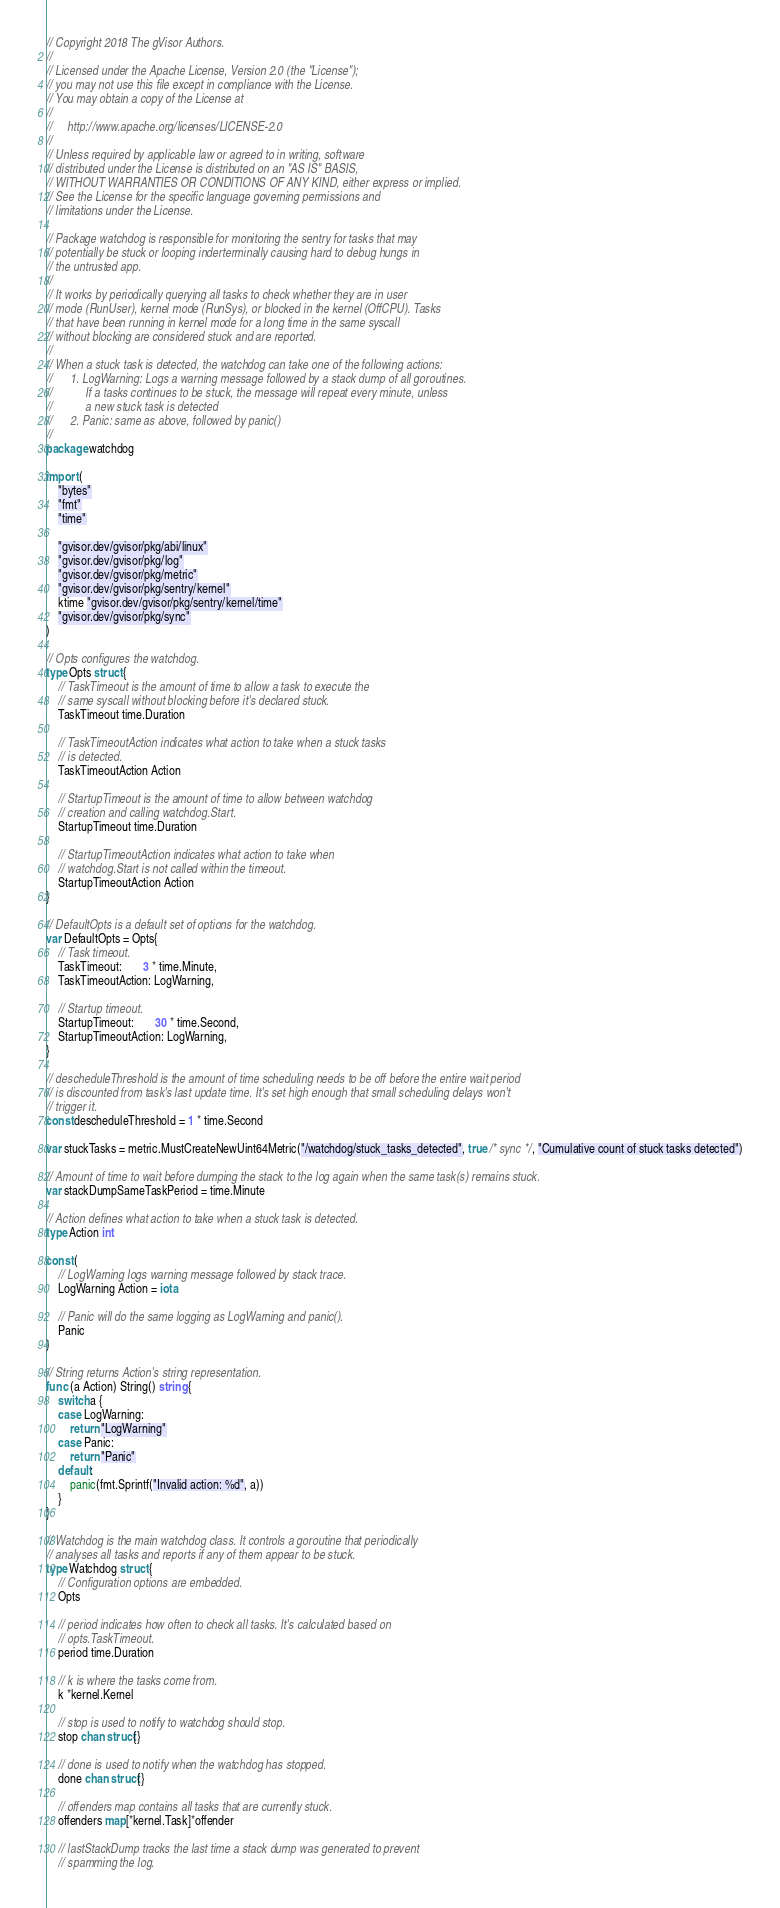<code> <loc_0><loc_0><loc_500><loc_500><_Go_>// Copyright 2018 The gVisor Authors.
//
// Licensed under the Apache License, Version 2.0 (the "License");
// you may not use this file except in compliance with the License.
// You may obtain a copy of the License at
//
//     http://www.apache.org/licenses/LICENSE-2.0
//
// Unless required by applicable law or agreed to in writing, software
// distributed under the License is distributed on an "AS IS" BASIS,
// WITHOUT WARRANTIES OR CONDITIONS OF ANY KIND, either express or implied.
// See the License for the specific language governing permissions and
// limitations under the License.

// Package watchdog is responsible for monitoring the sentry for tasks that may
// potentially be stuck or looping inderterminally causing hard to debug hungs in
// the untrusted app.
//
// It works by periodically querying all tasks to check whether they are in user
// mode (RunUser), kernel mode (RunSys), or blocked in the kernel (OffCPU). Tasks
// that have been running in kernel mode for a long time in the same syscall
// without blocking are considered stuck and are reported.
//
// When a stuck task is detected, the watchdog can take one of the following actions:
//		1. LogWarning: Logs a warning message followed by a stack dump of all goroutines.
//			 If a tasks continues to be stuck, the message will repeat every minute, unless
//			 a new stuck task is detected
//		2. Panic: same as above, followed by panic()
//
package watchdog

import (
	"bytes"
	"fmt"
	"time"

	"gvisor.dev/gvisor/pkg/abi/linux"
	"gvisor.dev/gvisor/pkg/log"
	"gvisor.dev/gvisor/pkg/metric"
	"gvisor.dev/gvisor/pkg/sentry/kernel"
	ktime "gvisor.dev/gvisor/pkg/sentry/kernel/time"
	"gvisor.dev/gvisor/pkg/sync"
)

// Opts configures the watchdog.
type Opts struct {
	// TaskTimeout is the amount of time to allow a task to execute the
	// same syscall without blocking before it's declared stuck.
	TaskTimeout time.Duration

	// TaskTimeoutAction indicates what action to take when a stuck tasks
	// is detected.
	TaskTimeoutAction Action

	// StartupTimeout is the amount of time to allow between watchdog
	// creation and calling watchdog.Start.
	StartupTimeout time.Duration

	// StartupTimeoutAction indicates what action to take when
	// watchdog.Start is not called within the timeout.
	StartupTimeoutAction Action
}

// DefaultOpts is a default set of options for the watchdog.
var DefaultOpts = Opts{
	// Task timeout.
	TaskTimeout:       3 * time.Minute,
	TaskTimeoutAction: LogWarning,

	// Startup timeout.
	StartupTimeout:       30 * time.Second,
	StartupTimeoutAction: LogWarning,
}

// descheduleThreshold is the amount of time scheduling needs to be off before the entire wait period
// is discounted from task's last update time. It's set high enough that small scheduling delays won't
// trigger it.
const descheduleThreshold = 1 * time.Second

var stuckTasks = metric.MustCreateNewUint64Metric("/watchdog/stuck_tasks_detected", true /* sync */, "Cumulative count of stuck tasks detected")

// Amount of time to wait before dumping the stack to the log again when the same task(s) remains stuck.
var stackDumpSameTaskPeriod = time.Minute

// Action defines what action to take when a stuck task is detected.
type Action int

const (
	// LogWarning logs warning message followed by stack trace.
	LogWarning Action = iota

	// Panic will do the same logging as LogWarning and panic().
	Panic
)

// String returns Action's string representation.
func (a Action) String() string {
	switch a {
	case LogWarning:
		return "LogWarning"
	case Panic:
		return "Panic"
	default:
		panic(fmt.Sprintf("Invalid action: %d", a))
	}
}

// Watchdog is the main watchdog class. It controls a goroutine that periodically
// analyses all tasks and reports if any of them appear to be stuck.
type Watchdog struct {
	// Configuration options are embedded.
	Opts

	// period indicates how often to check all tasks. It's calculated based on
	// opts.TaskTimeout.
	period time.Duration

	// k is where the tasks come from.
	k *kernel.Kernel

	// stop is used to notify to watchdog should stop.
	stop chan struct{}

	// done is used to notify when the watchdog has stopped.
	done chan struct{}

	// offenders map contains all tasks that are currently stuck.
	offenders map[*kernel.Task]*offender

	// lastStackDump tracks the last time a stack dump was generated to prevent
	// spamming the log.</code> 